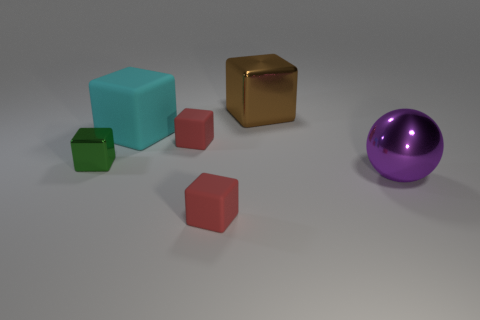Subtract all brown cubes. How many cubes are left? 4 Subtract all blue cubes. Subtract all gray spheres. How many cubes are left? 5 Add 3 red matte cylinders. How many objects exist? 9 Subtract all balls. How many objects are left? 5 Add 2 large cyan matte blocks. How many large cyan matte blocks are left? 3 Add 2 small green matte cubes. How many small green matte cubes exist? 2 Subtract 0 yellow spheres. How many objects are left? 6 Subtract all purple shiny things. Subtract all tiny metal cubes. How many objects are left? 4 